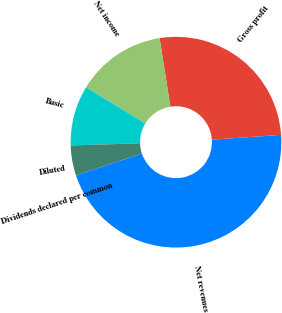Convert chart to OTSL. <chart><loc_0><loc_0><loc_500><loc_500><pie_chart><fcel>Net revenues<fcel>Gross profit<fcel>Net income<fcel>Basic<fcel>Diluted<fcel>Dividends declared per common<nl><fcel>46.01%<fcel>26.38%<fcel>13.8%<fcel>9.2%<fcel>4.6%<fcel>0.0%<nl></chart> 